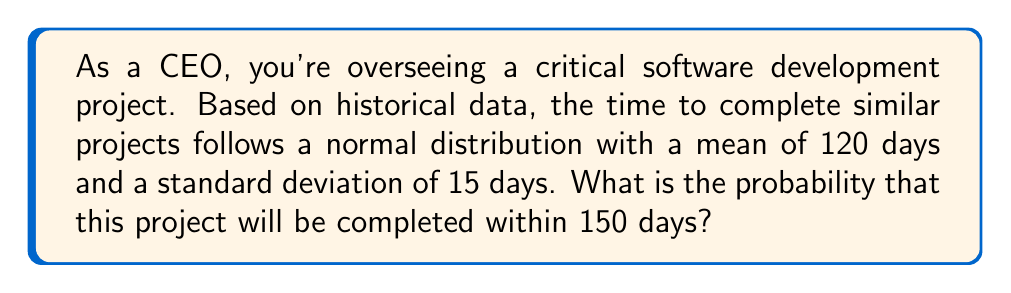Can you answer this question? To solve this problem, we need to use the properties of the normal distribution and calculate the z-score.

1. First, let's identify the given information:
   - Mean (μ) = 120 days
   - Standard deviation (σ) = 15 days
   - Time we're interested in (x) = 150 days

2. Calculate the z-score:
   The z-score formula is: $z = \frac{x - \mu}{\sigma}$
   
   Plugging in our values:
   $$z = \frac{150 - 120}{15} = \frac{30}{15} = 2$$

3. Now that we have the z-score, we need to find the area under the standard normal curve to the left of z = 2.

4. Using a standard normal distribution table or a calculator with this function, we find that the area to the left of z = 2 is approximately 0.9772.

5. This means that the probability of the project being completed within 150 days is about 0.9772 or 97.72%.

To visualize this:

[asy]
import graph;
import stats;

size(200,100);

real f(real x) {return exp(-x^2/2)/sqrt(2pi);}

draw(graph(f,-4,4));
fill(graph(f,-4,2), gray(0.7));

label("$\mu=120$", (0,-0.05));
label("$x=150$", (2,-0.05));

draw((2,0)--(2,f(2)), dashed);
[/asy]

The shaded area represents the probability of completing the project within 150 days.
Answer: The probability that the project will be completed within 150 days is approximately 0.9772 or 97.72%. 